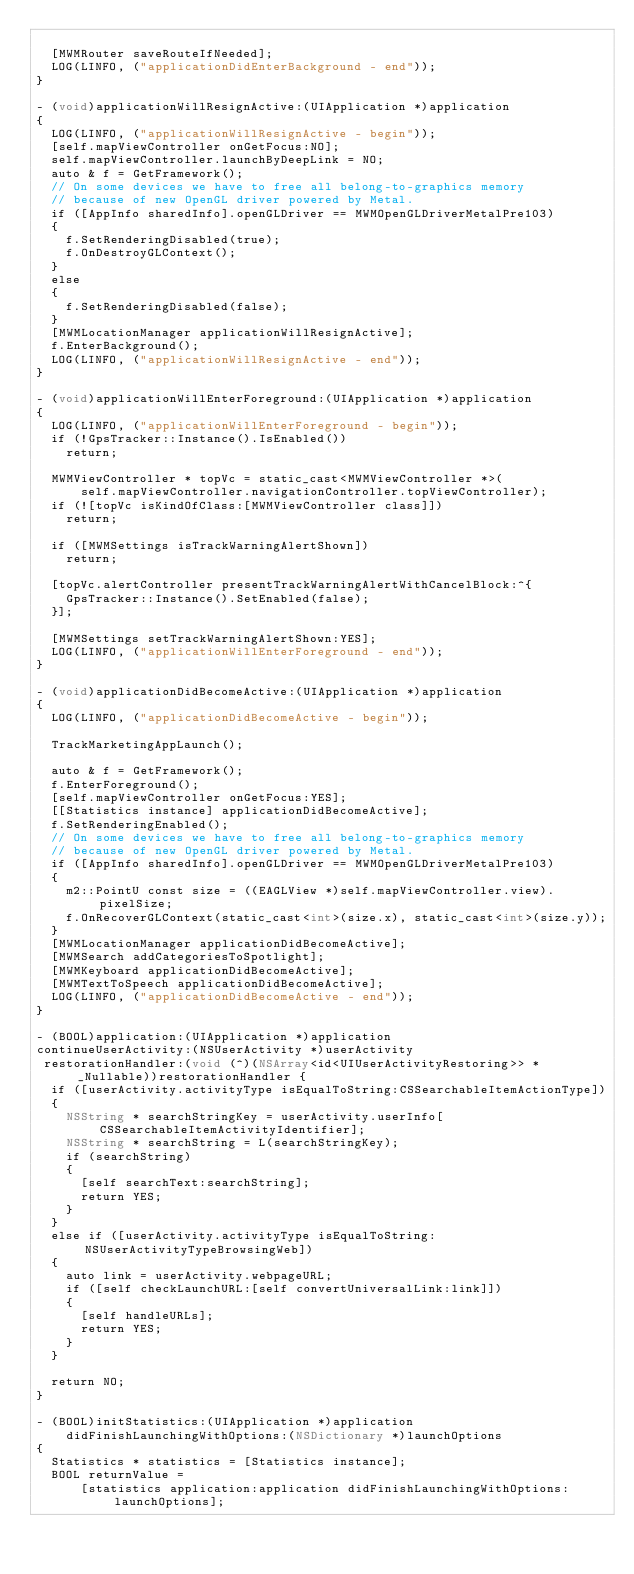<code> <loc_0><loc_0><loc_500><loc_500><_ObjectiveC_>
  [MWMRouter saveRouteIfNeeded];
  LOG(LINFO, ("applicationDidEnterBackground - end"));
}

- (void)applicationWillResignActive:(UIApplication *)application
{
  LOG(LINFO, ("applicationWillResignActive - begin"));
  [self.mapViewController onGetFocus:NO];
  self.mapViewController.launchByDeepLink = NO;
  auto & f = GetFramework();
  // On some devices we have to free all belong-to-graphics memory
  // because of new OpenGL driver powered by Metal.
  if ([AppInfo sharedInfo].openGLDriver == MWMOpenGLDriverMetalPre103)
  {
    f.SetRenderingDisabled(true);
    f.OnDestroyGLContext();
  }
  else
  {
    f.SetRenderingDisabled(false);
  }
  [MWMLocationManager applicationWillResignActive];
  f.EnterBackground();
  LOG(LINFO, ("applicationWillResignActive - end"));
}

- (void)applicationWillEnterForeground:(UIApplication *)application
{
  LOG(LINFO, ("applicationWillEnterForeground - begin"));
  if (!GpsTracker::Instance().IsEnabled())
    return;

  MWMViewController * topVc = static_cast<MWMViewController *>(
      self.mapViewController.navigationController.topViewController);
  if (![topVc isKindOfClass:[MWMViewController class]])
    return;

  if ([MWMSettings isTrackWarningAlertShown])
    return;

  [topVc.alertController presentTrackWarningAlertWithCancelBlock:^{
    GpsTracker::Instance().SetEnabled(false);
  }];

  [MWMSettings setTrackWarningAlertShown:YES];
  LOG(LINFO, ("applicationWillEnterForeground - end"));
}

- (void)applicationDidBecomeActive:(UIApplication *)application
{
  LOG(LINFO, ("applicationDidBecomeActive - begin"));
  
  TrackMarketingAppLaunch();
  
  auto & f = GetFramework();
  f.EnterForeground();
  [self.mapViewController onGetFocus:YES];
  [[Statistics instance] applicationDidBecomeActive];
  f.SetRenderingEnabled();
  // On some devices we have to free all belong-to-graphics memory
  // because of new OpenGL driver powered by Metal.
  if ([AppInfo sharedInfo].openGLDriver == MWMOpenGLDriverMetalPre103)
  {
    m2::PointU const size = ((EAGLView *)self.mapViewController.view).pixelSize;
    f.OnRecoverGLContext(static_cast<int>(size.x), static_cast<int>(size.y));
  }
  [MWMLocationManager applicationDidBecomeActive];
  [MWMSearch addCategoriesToSpotlight];
  [MWMKeyboard applicationDidBecomeActive];
  [MWMTextToSpeech applicationDidBecomeActive];
  LOG(LINFO, ("applicationDidBecomeActive - end"));
}

- (BOOL)application:(UIApplication *)application
continueUserActivity:(NSUserActivity *)userActivity
 restorationHandler:(void (^)(NSArray<id<UIUserActivityRestoring>> * _Nullable))restorationHandler {
  if ([userActivity.activityType isEqualToString:CSSearchableItemActionType])
  {
    NSString * searchStringKey = userActivity.userInfo[CSSearchableItemActivityIdentifier];
    NSString * searchString = L(searchStringKey);
    if (searchString)
    {
      [self searchText:searchString];
      return YES;
    }
  }
  else if ([userActivity.activityType isEqualToString:NSUserActivityTypeBrowsingWeb])
  {
    auto link = userActivity.webpageURL;
    if ([self checkLaunchURL:[self convertUniversalLink:link]])
    {
      [self handleURLs];
      return YES;
    }
  }

  return NO;
}

- (BOOL)initStatistics:(UIApplication *)application
    didFinishLaunchingWithOptions:(NSDictionary *)launchOptions
{
  Statistics * statistics = [Statistics instance];
  BOOL returnValue =
      [statistics application:application didFinishLaunchingWithOptions:launchOptions];
</code> 